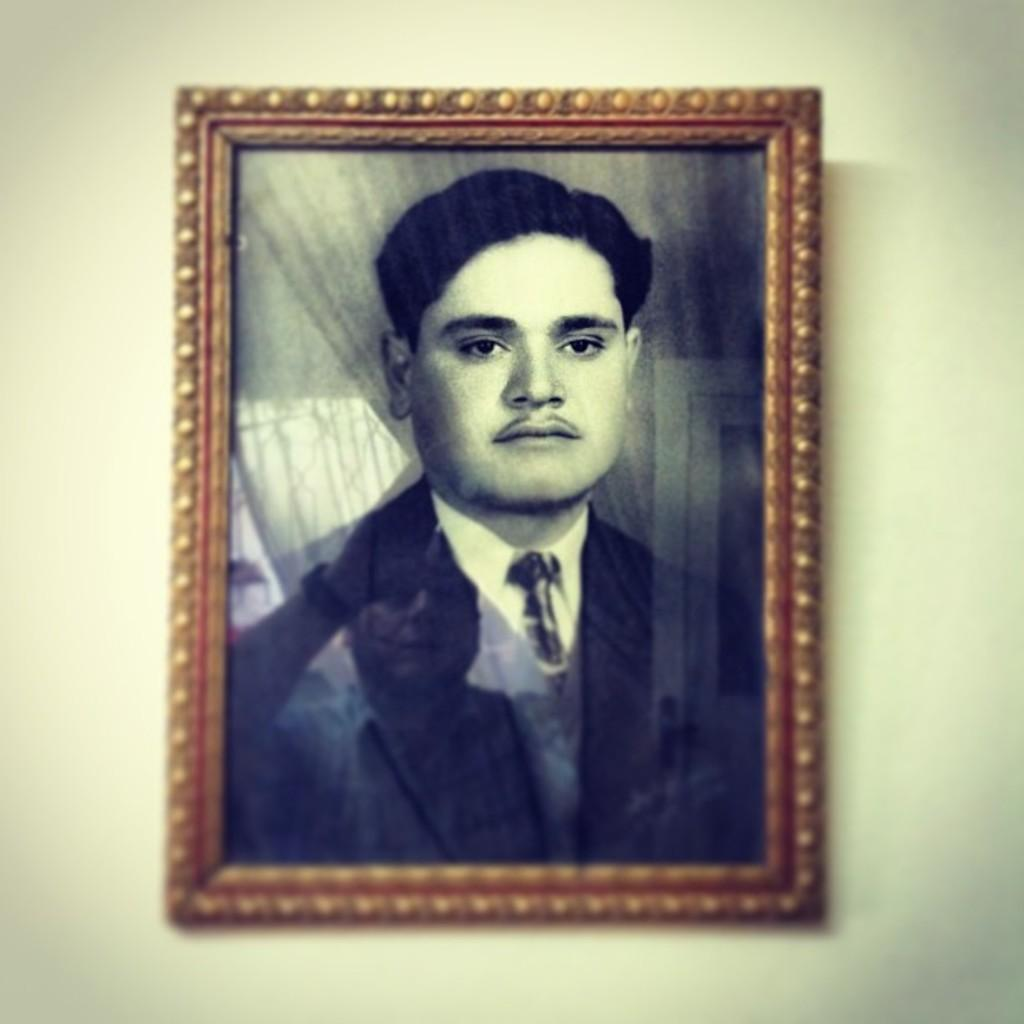What object is present in the image that typically holds a photograph? There is a photo frame in the image. Can you describe the main subject of the image? There is a person in the image. What color is the background of the image? The background of the image is white. How many bells can be seen hanging from the person's neck in the image? There are no bells visible in the image; the person is not wearing any. What type of animal is depicted in the image with the geese? There are no animals, including geese or kitties, present in the image. 